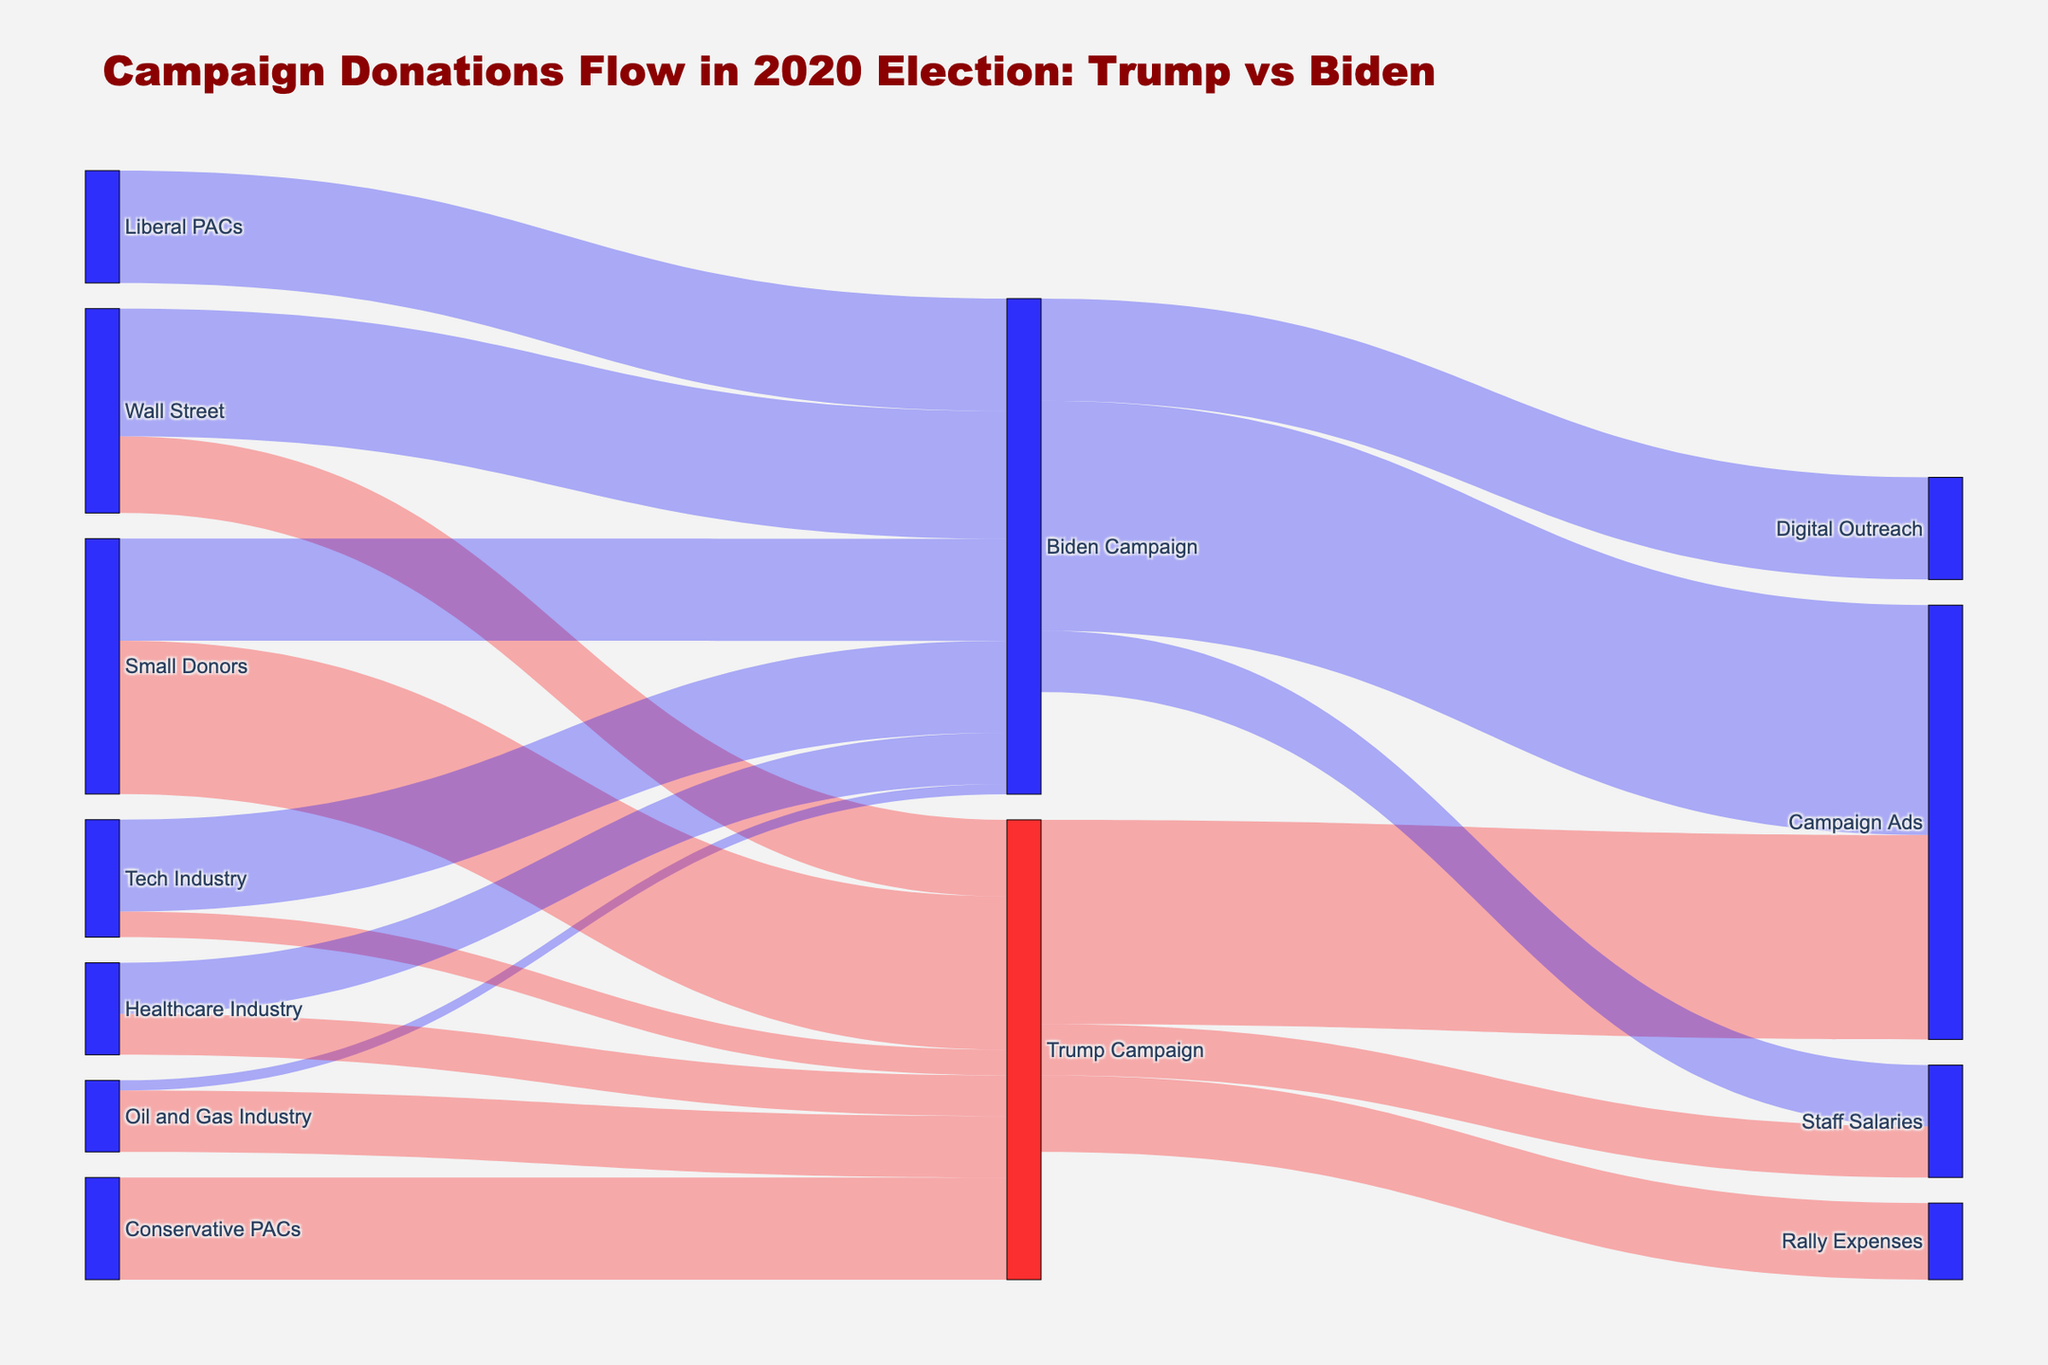Which sector contributed the most to Trump's campaign? Look at the flows pointing towards "Trump Campaign" and find the largest one. The "Small Donors" sector has a value of 30 million, which is the highest.
Answer: Small Donors How much did Trump spend on Campaign Ads? Find the flow going from "Trump Campaign" to "Campaign Ads" and note the value, which is 40 million.
Answer: 40 million Which candidate received more from the Wall Street sector? Compare the flows from "Wall Street" to "Trump Campaign" and "Wall Street" to "Biden Campaign". Biden received 25 million while Trump received 15 million.
Answer: Biden What is the total amount contributed by the Tech Industry? Sum the contributions from Tech Industry to both campaigns. Tech Industry contributed 5 million to Trump and 18 million to Biden, totaling 23 million.
Answer: 23 million How do the contributions from the Oil and Gas Industry compare between Trump and Biden? Look at the flows from "Oil and Gas Industry" to both campaigns. Trump received 12 million and Biden received 2 million. Trump received more.
Answer: Trump received more What is the combined amount spent on Staff Salaries by both campaigns? Sum the values of the flows from both campaigns to Staff Salaries. Trump spent 10 million and Biden spent 12 million, totaling 22 million.
Answer: 22 million If we consider only the PAC contributions, which candidate received more money? Compare the combined contributions from Conservative PACs to Trump and Liberal PACs to Biden. Conservative PACs gave 20 million to Trump, while Liberal PACs gave 22 million to Biden. Biden received more.
Answer: Biden What is the contribution difference between Wall Street to Trump and Wall Street to Biden? Subtract the contribution to Trump from the contribution to Biden. Biden received 25 million while Trump received 15 million. So, the difference is 25 - 15 = 10 million.
Answer: 10 million Which of the campaign expenses for Trump received the least funding? Look at the flows from "Trump Campaign" and find the smallest one. Rally Expenses received 15 million, which is the least among Campaign Ads, Rally Expenses, and Staff Salaries.
Answer: Rally Expenses 